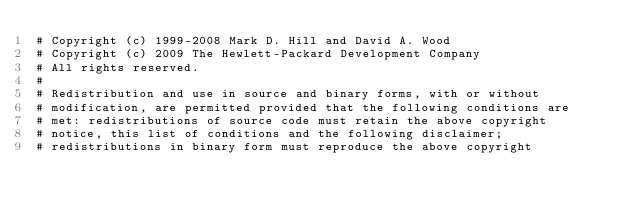Convert code to text. <code><loc_0><loc_0><loc_500><loc_500><_Python_># Copyright (c) 1999-2008 Mark D. Hill and David A. Wood
# Copyright (c) 2009 The Hewlett-Packard Development Company
# All rights reserved.
#
# Redistribution and use in source and binary forms, with or without
# modification, are permitted provided that the following conditions are
# met: redistributions of source code must retain the above copyright
# notice, this list of conditions and the following disclaimer;
# redistributions in binary form must reproduce the above copyright</code> 